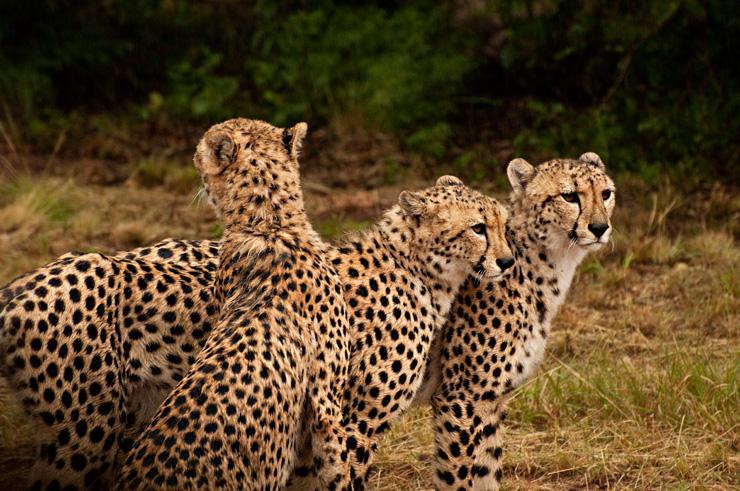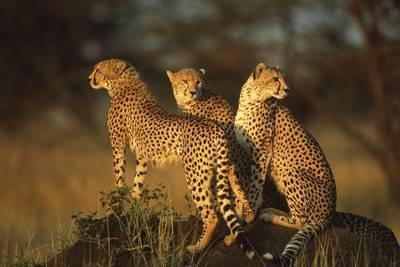The first image is the image on the left, the second image is the image on the right. Evaluate the accuracy of this statement regarding the images: "Right image shows three cheetahs looking in a variety of directions.". Is it true? Answer yes or no. Yes. The first image is the image on the left, the second image is the image on the right. Considering the images on both sides, is "The image on the right has no more than three cheetahs." valid? Answer yes or no. Yes. 